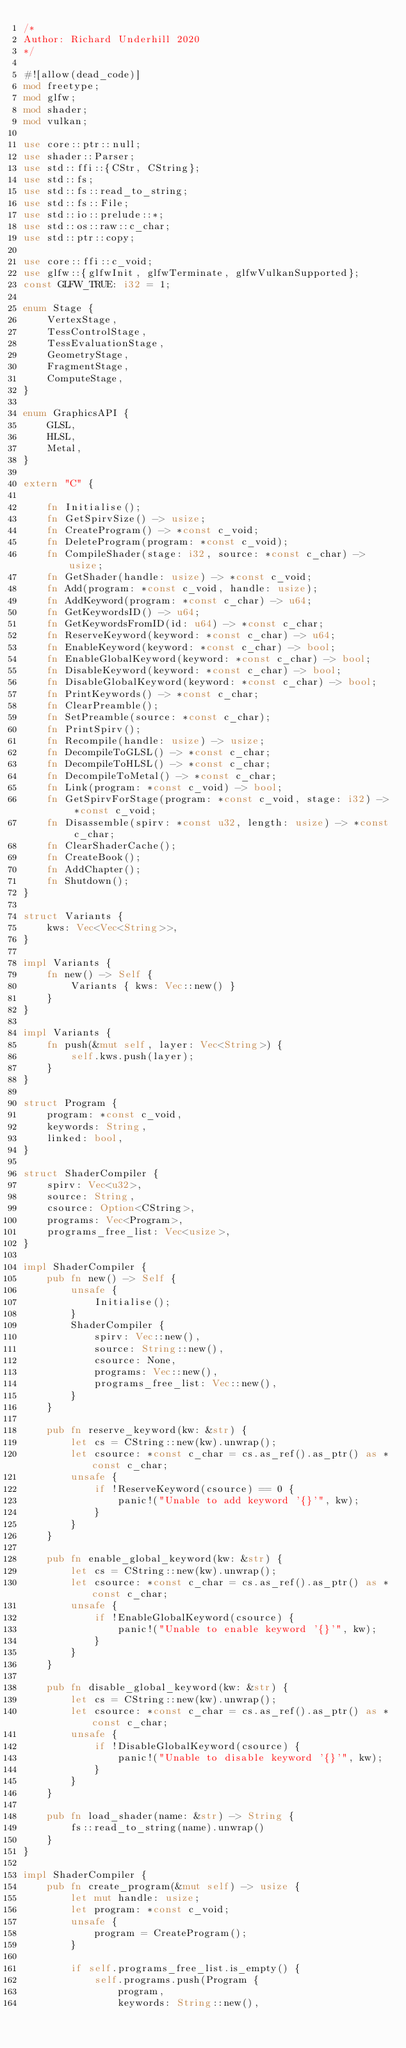<code> <loc_0><loc_0><loc_500><loc_500><_Rust_>/*
Author: Richard Underhill 2020
*/

#![allow(dead_code)]
mod freetype;
mod glfw;
mod shader;
mod vulkan;

use core::ptr::null;
use shader::Parser;
use std::ffi::{CStr, CString};
use std::fs;
use std::fs::read_to_string;
use std::fs::File;
use std::io::prelude::*;
use std::os::raw::c_char;
use std::ptr::copy;

use core::ffi::c_void;
use glfw::{glfwInit, glfwTerminate, glfwVulkanSupported};
const GLFW_TRUE: i32 = 1;

enum Stage {
    VertexStage,
    TessControlStage,
    TessEvaluationStage,
    GeometryStage,
    FragmentStage,
    ComputeStage,
}

enum GraphicsAPI {
    GLSL,
    HLSL,
    Metal,
}

extern "C" {

    fn Initialise();
    fn GetSpirvSize() -> usize;
    fn CreateProgram() -> *const c_void;
    fn DeleteProgram(program: *const c_void);
    fn CompileShader(stage: i32, source: *const c_char) -> usize;
    fn GetShader(handle: usize) -> *const c_void;
    fn Add(program: *const c_void, handle: usize);
    fn AddKeyword(program: *const c_char) -> u64;
    fn GetKeywordsID() -> u64;
    fn GetKeywordsFromID(id: u64) -> *const c_char;
    fn ReserveKeyword(keyword: *const c_char) -> u64;
    fn EnableKeyword(keyword: *const c_char) -> bool;
    fn EnableGlobalKeyword(keyword: *const c_char) -> bool;
    fn DisableKeyword(keyword: *const c_char) -> bool;
    fn DisableGlobalKeyword(keyword: *const c_char) -> bool;
    fn PrintKeywords() -> *const c_char;
    fn ClearPreamble();
    fn SetPreamble(source: *const c_char);
    fn PrintSpirv();
    fn Recompile(handle: usize) -> usize;
    fn DecompileToGLSL() -> *const c_char;
    fn DecompileToHLSL() -> *const c_char;
    fn DecompileToMetal() -> *const c_char;
    fn Link(program: *const c_void) -> bool;
    fn GetSpirvForStage(program: *const c_void, stage: i32) -> *const c_void;
    fn Disassemble(spirv: *const u32, length: usize) -> *const c_char;
    fn ClearShaderCache();
    fn CreateBook();
    fn AddChapter();
    fn Shutdown();
}

struct Variants {
    kws: Vec<Vec<String>>,
}

impl Variants {
    fn new() -> Self {
        Variants { kws: Vec::new() }
    }
}

impl Variants {
    fn push(&mut self, layer: Vec<String>) {
        self.kws.push(layer);
    }
}

struct Program {
    program: *const c_void,
    keywords: String,
    linked: bool,
}

struct ShaderCompiler {
    spirv: Vec<u32>,
    source: String,
    csource: Option<CString>,
    programs: Vec<Program>,
    programs_free_list: Vec<usize>,
}

impl ShaderCompiler {
    pub fn new() -> Self {
        unsafe {
            Initialise();
        }
        ShaderCompiler {
            spirv: Vec::new(),
            source: String::new(),
            csource: None,
            programs: Vec::new(),
            programs_free_list: Vec::new(),
        }
    }

    pub fn reserve_keyword(kw: &str) {
        let cs = CString::new(kw).unwrap();
        let csource: *const c_char = cs.as_ref().as_ptr() as *const c_char;
        unsafe {
            if !ReserveKeyword(csource) == 0 {
                panic!("Unable to add keyword '{}'", kw);
            }
        }
    }

    pub fn enable_global_keyword(kw: &str) {
        let cs = CString::new(kw).unwrap();
        let csource: *const c_char = cs.as_ref().as_ptr() as *const c_char;
        unsafe {
            if !EnableGlobalKeyword(csource) {
                panic!("Unable to enable keyword '{}'", kw);
            }
        }
    }

    pub fn disable_global_keyword(kw: &str) {
        let cs = CString::new(kw).unwrap();
        let csource: *const c_char = cs.as_ref().as_ptr() as *const c_char;
        unsafe {
            if !DisableGlobalKeyword(csource) {
                panic!("Unable to disable keyword '{}'", kw);
            }
        }
    }

    pub fn load_shader(name: &str) -> String {
        fs::read_to_string(name).unwrap()
    }
}

impl ShaderCompiler {
    pub fn create_program(&mut self) -> usize {
        let mut handle: usize;
        let program: *const c_void;
        unsafe {
            program = CreateProgram();
        }

        if self.programs_free_list.is_empty() {
            self.programs.push(Program {
                program,
                keywords: String::new(),</code> 